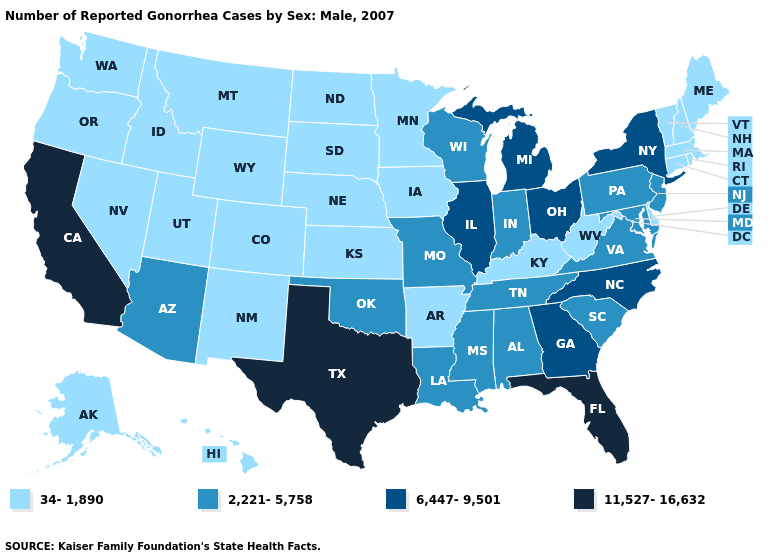What is the lowest value in the USA?
Quick response, please. 34-1,890. Which states have the lowest value in the Northeast?
Short answer required. Connecticut, Maine, Massachusetts, New Hampshire, Rhode Island, Vermont. What is the value of Louisiana?
Be succinct. 2,221-5,758. What is the value of South Dakota?
Quick response, please. 34-1,890. What is the value of West Virginia?
Give a very brief answer. 34-1,890. Which states have the highest value in the USA?
Write a very short answer. California, Florida, Texas. Name the states that have a value in the range 11,527-16,632?
Write a very short answer. California, Florida, Texas. What is the highest value in states that border Utah?
Give a very brief answer. 2,221-5,758. Does New Jersey have the lowest value in the USA?
Concise answer only. No. Does Michigan have the lowest value in the USA?
Write a very short answer. No. Which states have the highest value in the USA?
Give a very brief answer. California, Florida, Texas. What is the value of North Carolina?
Short answer required. 6,447-9,501. How many symbols are there in the legend?
Keep it brief. 4. What is the value of Rhode Island?
Write a very short answer. 34-1,890. Among the states that border New Mexico , which have the highest value?
Give a very brief answer. Texas. 